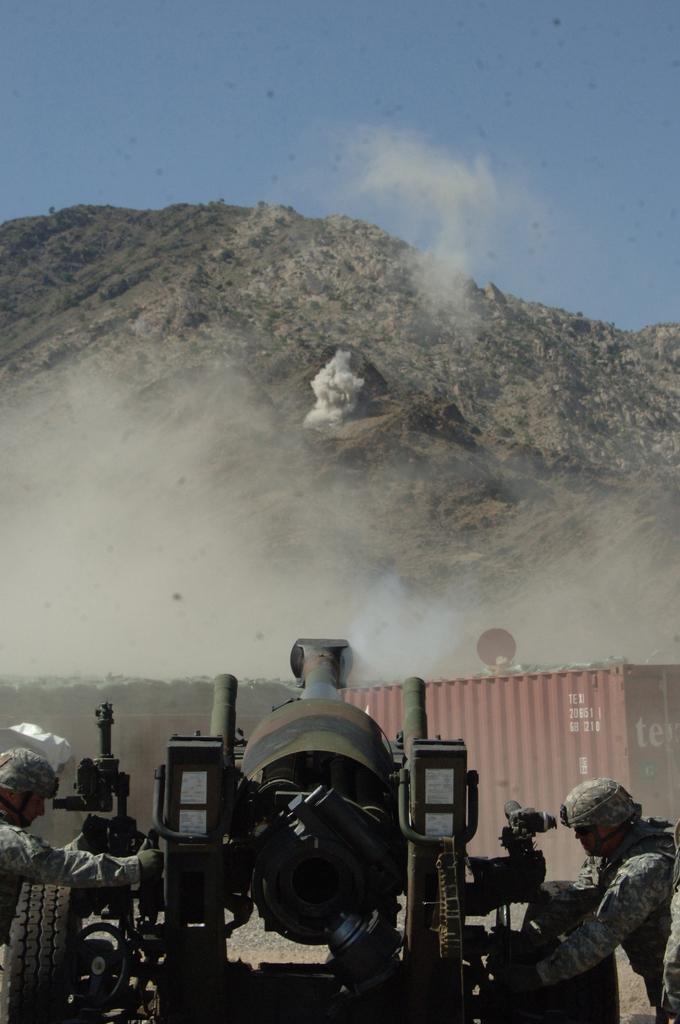Could you give a brief overview of what you see in this image? In this image we can see two persons, there is a tanker, also we can see the mountain, and the sky. 